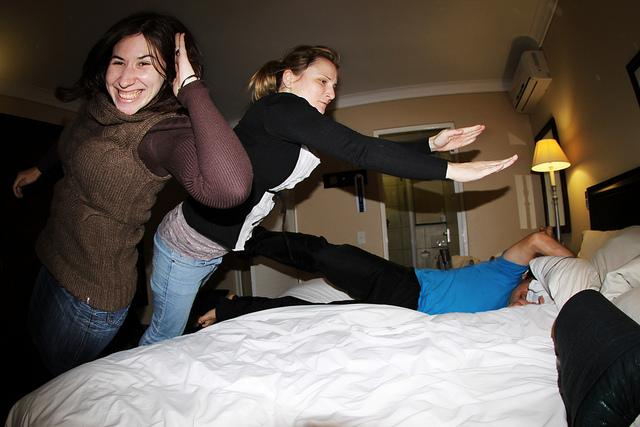Where are these people?

Choices:
A) car dealership
B) spa
C) hotel room
D) outside hotel room 